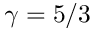Convert formula to latex. <formula><loc_0><loc_0><loc_500><loc_500>\gamma = 5 / 3</formula> 